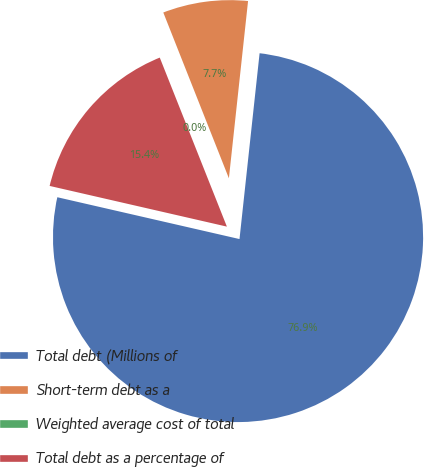<chart> <loc_0><loc_0><loc_500><loc_500><pie_chart><fcel>Total debt (Millions of<fcel>Short-term debt as a<fcel>Weighted average cost of total<fcel>Total debt as a percentage of<nl><fcel>76.87%<fcel>7.71%<fcel>0.02%<fcel>15.39%<nl></chart> 